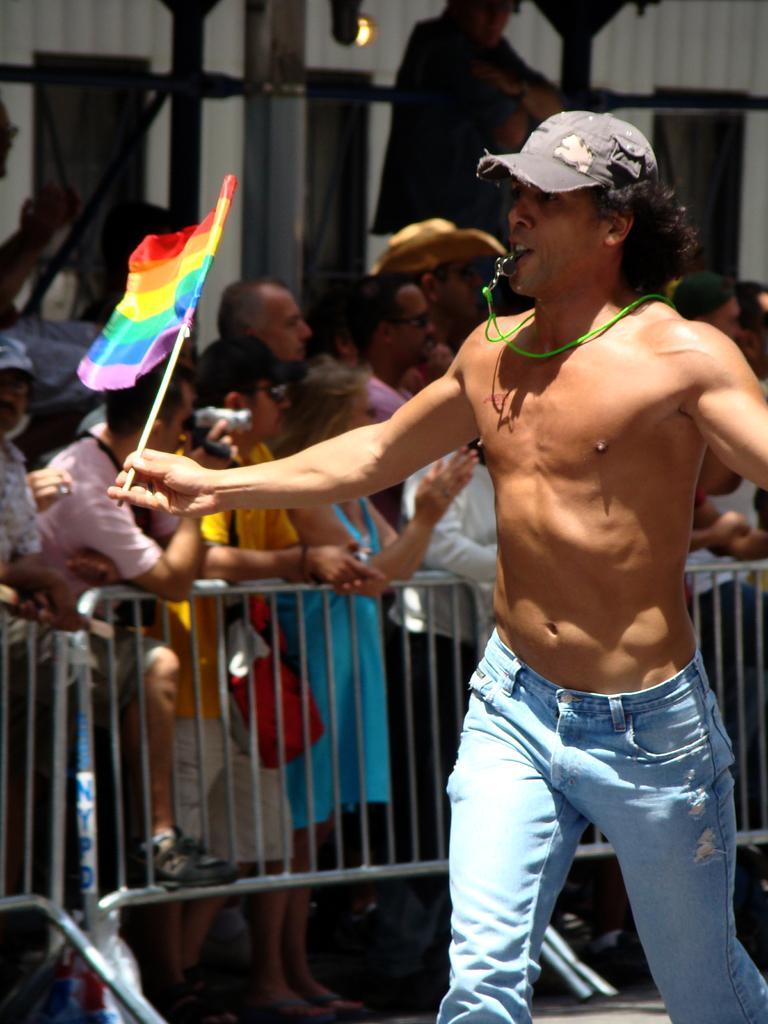Could you give a brief overview of what you see in this image? On the right side, there is a person without having a shirt holding a flag and running. In the background, there are barricades. Behind them, there are persons standing, there are poles, a wall and a light. 